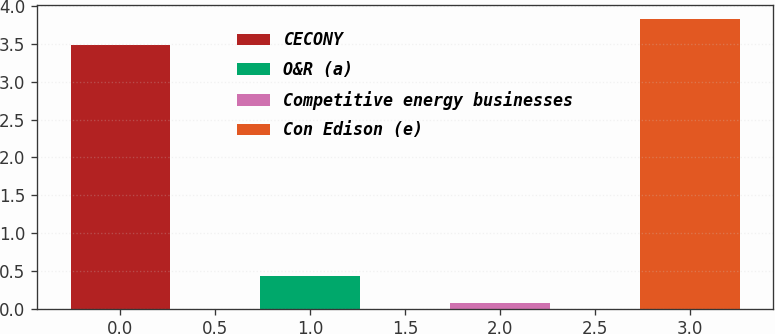Convert chart. <chart><loc_0><loc_0><loc_500><loc_500><bar_chart><fcel>CECONY<fcel>O&R (a)<fcel>Competitive energy businesses<fcel>Con Edison (e)<nl><fcel>3.48<fcel>0.43<fcel>0.08<fcel>3.83<nl></chart> 